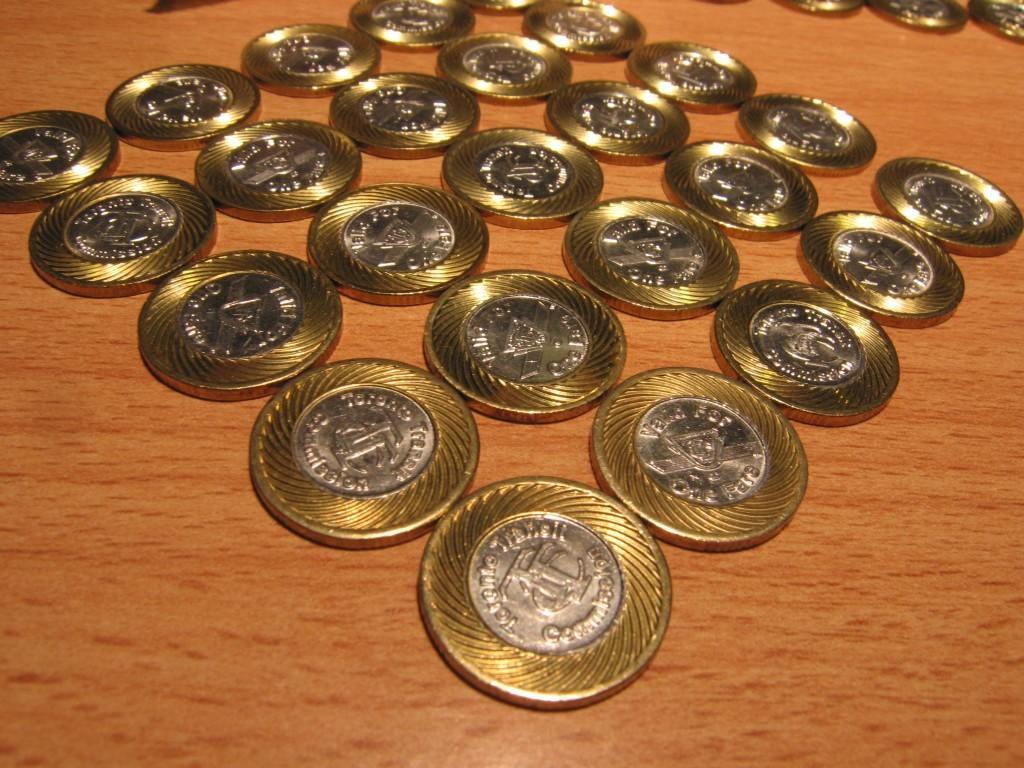Could you give a brief overview of what you see in this image? In this image we can see some coins on the wooden surface, which looks like a table. 